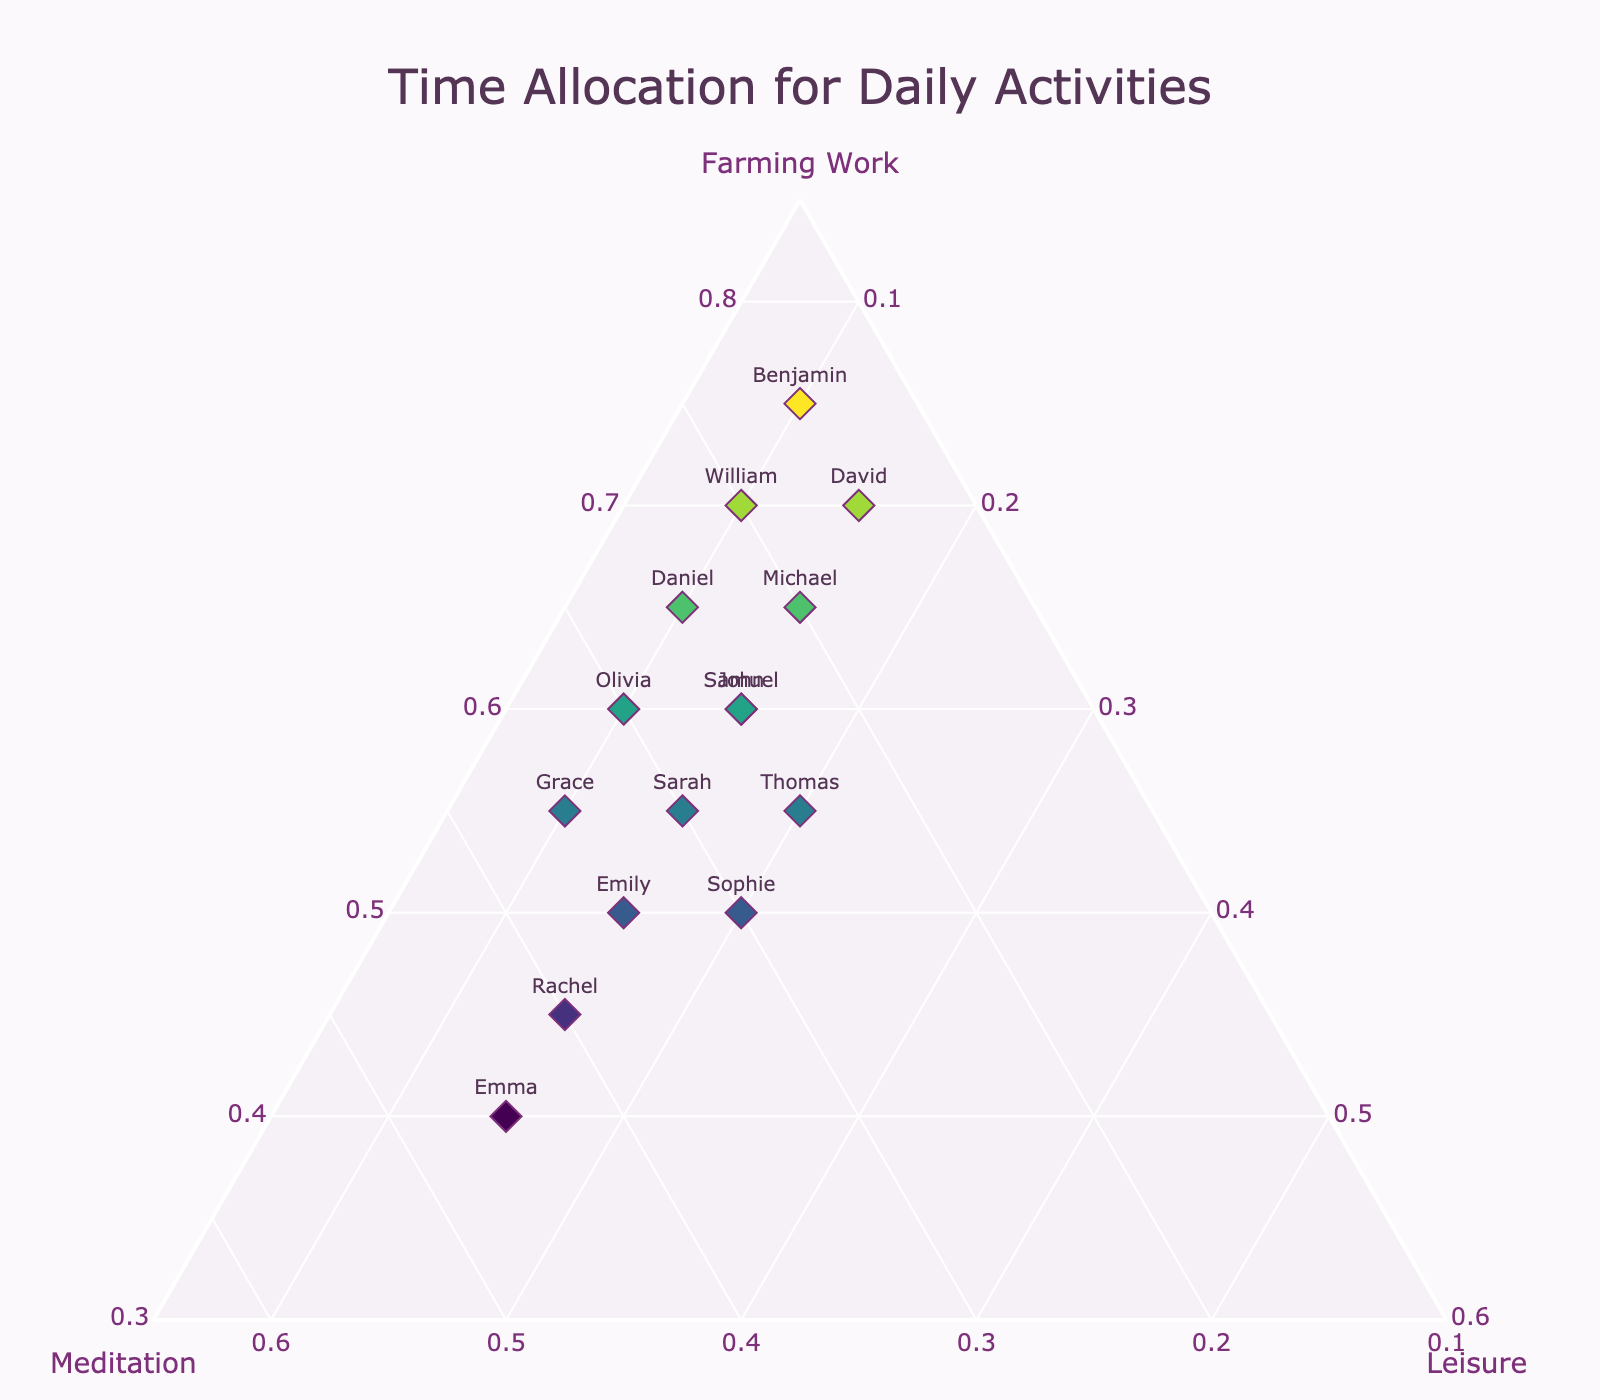How many farmers are represented in the figure? By counting the number of data points or markers in the ternary plot, we can determine the number of farmers represented.
Answer: 15 What is the title of the figure? The title is typically displayed prominently at the top of the figure, which is easy to read.
Answer: Time Allocation for Daily Activities Which farmer allocates the most time to meditation? By looking at the values along the meditation axis, find the highest value and check which farmer corresponds to it.
Answer: Emma How much time does John allocate to leisure? By locating John's marker on the ternary plot and reading the value along the leisure axis.
Answer: 15 Which two farmers allocate the exact same amount of time to leisure? By comparing the values along the leisure axis, check for any pairs with the same value.
Answer: John and Michael (both allocate 15 to leisure) What is the average time allocated to farming work by all farmers? Sum all the farming work values and divide by the number of farmers (60+55+65+50+70+45+55+60+65+50+75+40+70+55+60) / 15 = 55.33.
Answer: 55.33 Who spends more time on farming work, Sarah or Olivia? By comparing the farming work values of Sarah (55) and Olivia (60).
Answer: Olivia What unique aspect does the ternary plot show compared to a regular scatter plot? A ternary plot uniquely shows proportions among three aspects (farming work, meditation, leisure) simultaneously, giving a more detailed view of the trade-offs between them.
Answer: Proportions of three aspects simultaneously What is the total amount of time allocated to all activities by Sophie? Sum Sophie's time allocation for farming, meditation, and leisure: 50 + 30 + 20.
Answer: 100 Which farmer has the most balanced time allocation between the three activities? By finding the data point that is most centrally located within the ternary plot, indicating a more equal distribution among the three activities.
Answer: Thomas 